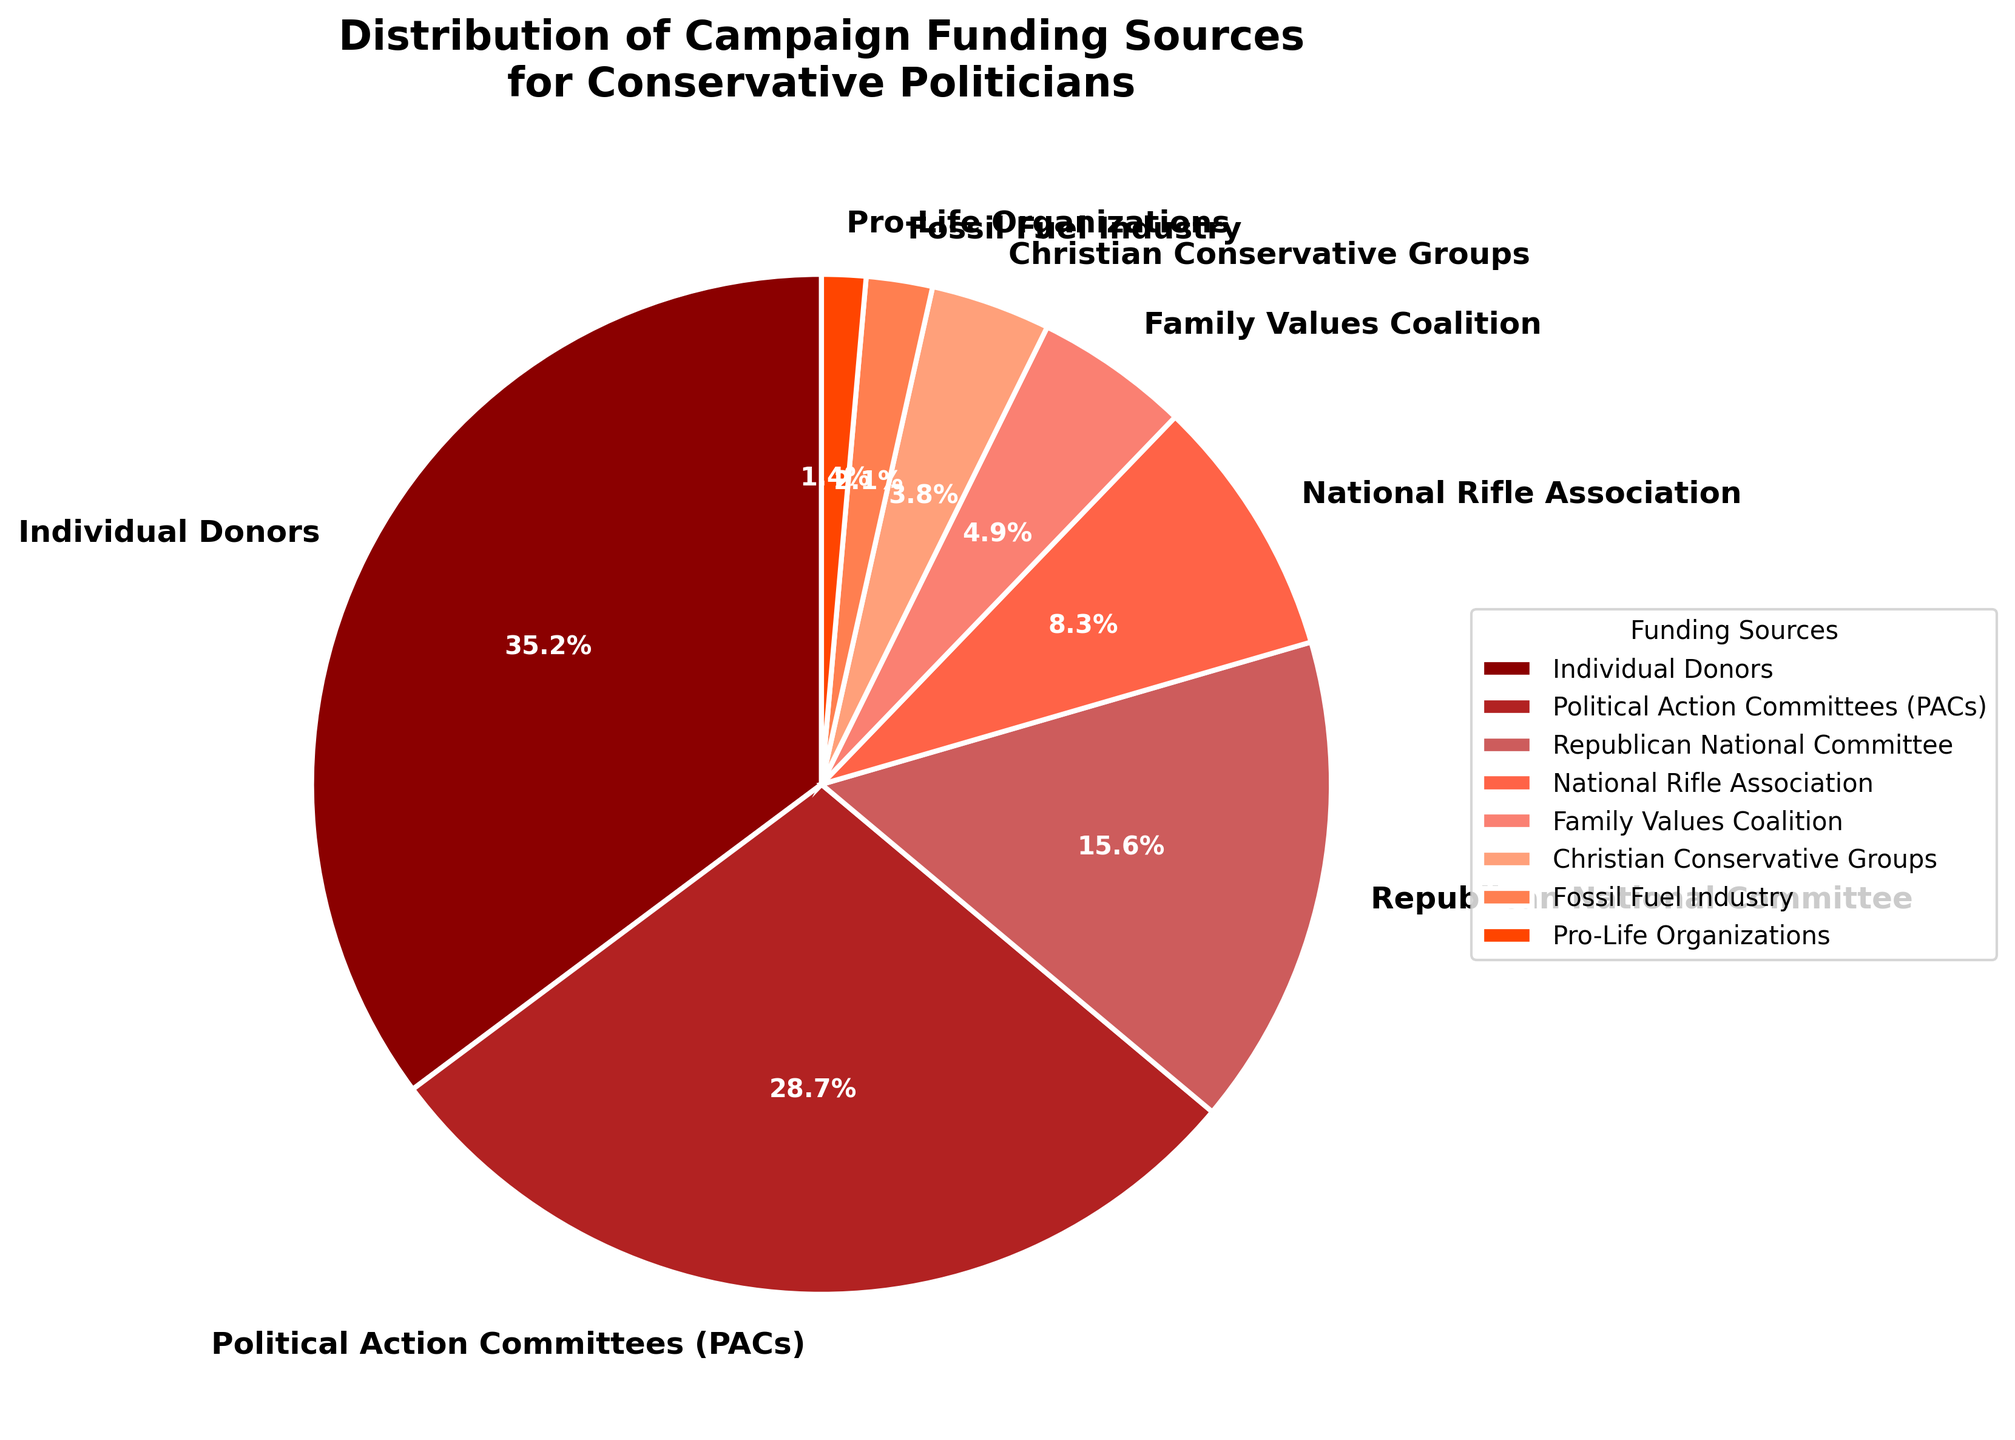What's the largest source of campaign funding? The pie chart shows the largest percentage of campaign funding is from Individual Donors, which is labeled with 35.2%.
Answer: Individual Donors What's the difference in percentage between contributions from Individual Donors and PACs? Individual Donors contribute 35.2%, and PACs contribute 28.7%. The difference is 35.2% - 28.7% = 6.5%.
Answer: 6.5% Which organization contributes the least to campaign funding? The smallest percentage in the pie chart is from Pro-Life Organizations, which contributes 1.4%.
Answer: Pro-Life Organizations How much more does the Family Values Coalition contribute compared to Christian Conservative Groups? Family Values Coalition contributes 4.9%, and Christian Conservative Groups contribute 3.8%. The difference is 4.9% - 3.8% = 1.1%.
Answer: 1.1% What is the combined contribution of Christian Conservative Groups and the Fossil Fuel Industry? Christian Conservative Groups contribute 3.8%, and the Fossil Fuel Industry contributes 2.1%. Their combined contribution is 3.8% + 2.1% = 5.9%.
Answer: 5.9% Which source has a contribution percentage closest to 10%? The National Rifle Association contributes 8.3%, which is the closest to 10% among all sources listed in the pie chart.
Answer: National Rifle Association How many funding sources contribute less than 5% each? The sources contributing less than 5% each are Family Values Coalition (4.9%), Christian Conservative Groups (3.8%), Fossil Fuel Industry (2.1%), and Pro-Life Organizations (1.4%). There are 4 such sources.
Answer: 4 By how much does the Republican National Committee's contribution exceed that of the National Rifle Association? The Republican National Committee contributes 15.6%, while the National Rifle Association contributes 8.3%. The difference is 15.6% - 8.3% = 7.3%.
Answer: 7.3% What is the total contribution percentage of Individual Donors, PACs, and the Republican National Committee combined? Individual Donors contribute 35.2%, PACs contribute 28.7%, and the Republican National Committee contributes 15.6%. Their combined total is 35.2% + 28.7% + 15.6% = 79.5%.
Answer: 79.5% 